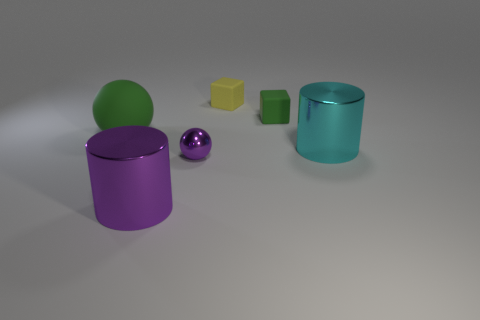Add 3 big gray rubber objects. How many objects exist? 9 Subtract all balls. How many objects are left? 4 Add 6 yellow things. How many yellow things are left? 7 Add 4 large rubber spheres. How many large rubber spheres exist? 5 Subtract all green blocks. How many blocks are left? 1 Subtract 0 cyan blocks. How many objects are left? 6 Subtract 2 cubes. How many cubes are left? 0 Subtract all yellow cylinders. Subtract all green spheres. How many cylinders are left? 2 Subtract all gray blocks. How many brown spheres are left? 0 Subtract all small spheres. Subtract all cyan cylinders. How many objects are left? 4 